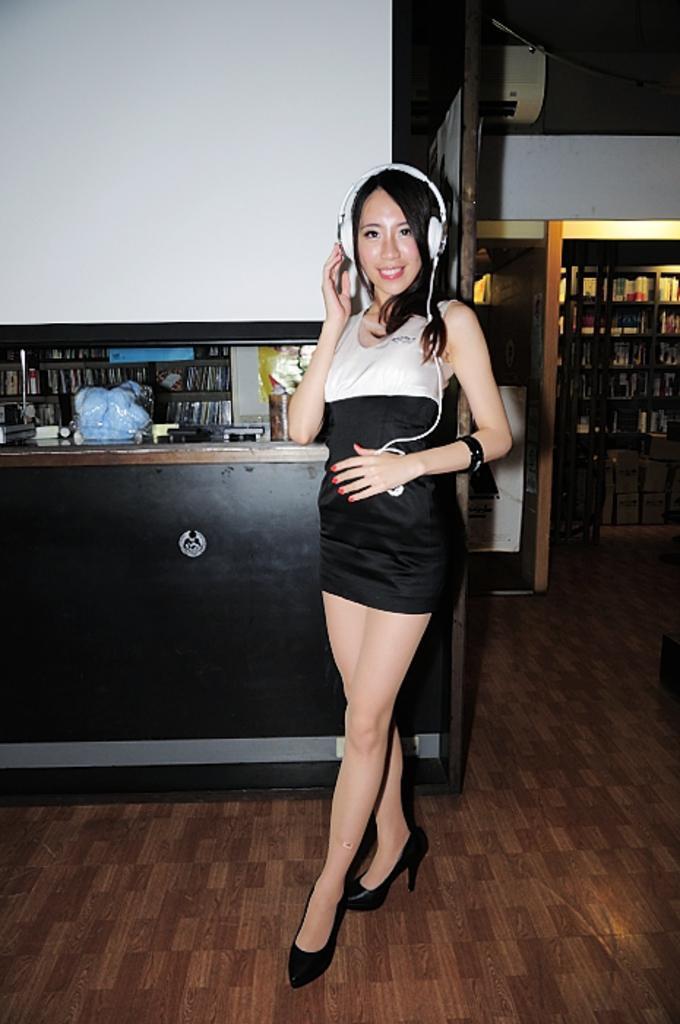Can you describe this image briefly? In this image in the center there is one woman standing, and she is wearing a headset. And in the background there are some shelves, in the shelves there are some objects and there is a wall, cupboards, boxes. And at the bottom there is floor. 